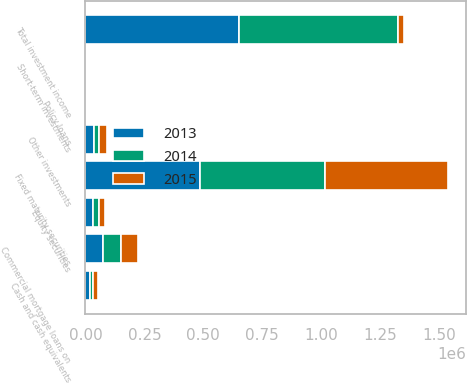Convert chart. <chart><loc_0><loc_0><loc_500><loc_500><stacked_bar_chart><ecel><fcel>Fixed maturity securities<fcel>Equity securities<fcel>Commercial mortgage loans on<fcel>Policy loans<fcel>Short-term investments<fcel>Other investments<fcel>Cash and cash equivalents<fcel>Total investment income<nl><fcel>2013<fcel>486165<fcel>29957<fcel>72658<fcel>2478<fcel>2033<fcel>37759<fcel>18416<fcel>649466<nl><fcel>2015<fcel>522309<fcel>28014<fcel>73959<fcel>2939<fcel>1950<fcel>34527<fcel>18556<fcel>28014<nl><fcel>2014<fcel>530144<fcel>27013<fcel>76665<fcel>3426<fcel>2156<fcel>20573<fcel>14679<fcel>674656<nl></chart> 